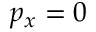<formula> <loc_0><loc_0><loc_500><loc_500>p _ { x } = 0</formula> 